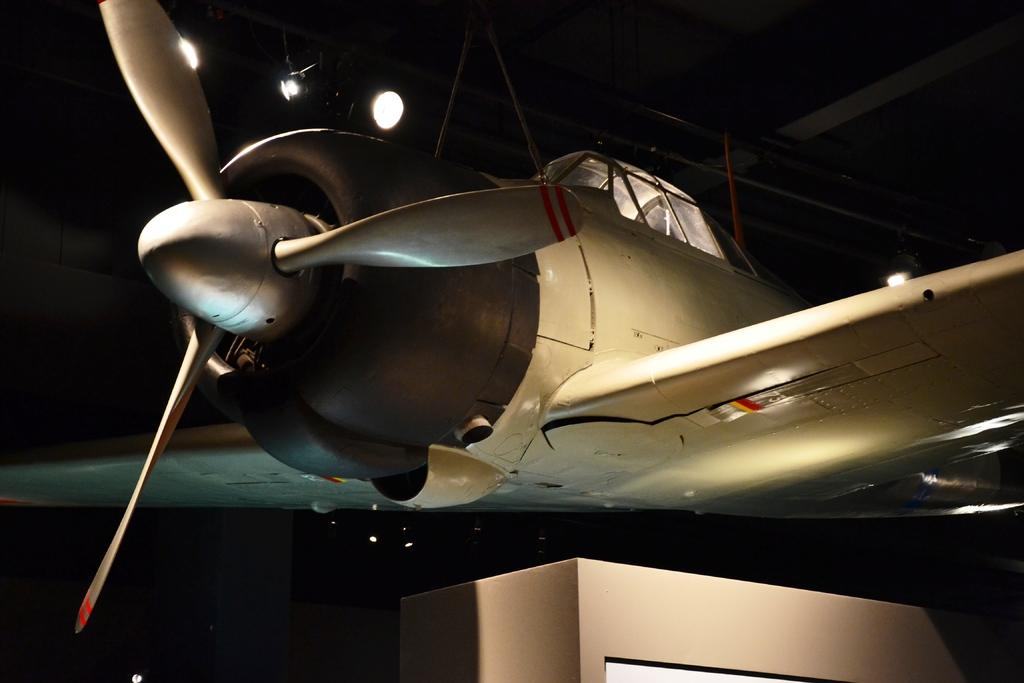What is the main subject of the image? The main subject of the image is an airplane. What can be seen in the background of the image? There are lights visible in the background of the image, and the background appears to be black. What is located at the bottom of the image? There is a box at the bottom of the image. What type of art is being agreed upon in the image? There is no art or agreement present in the image; it features an airplane and a black background with lights. 